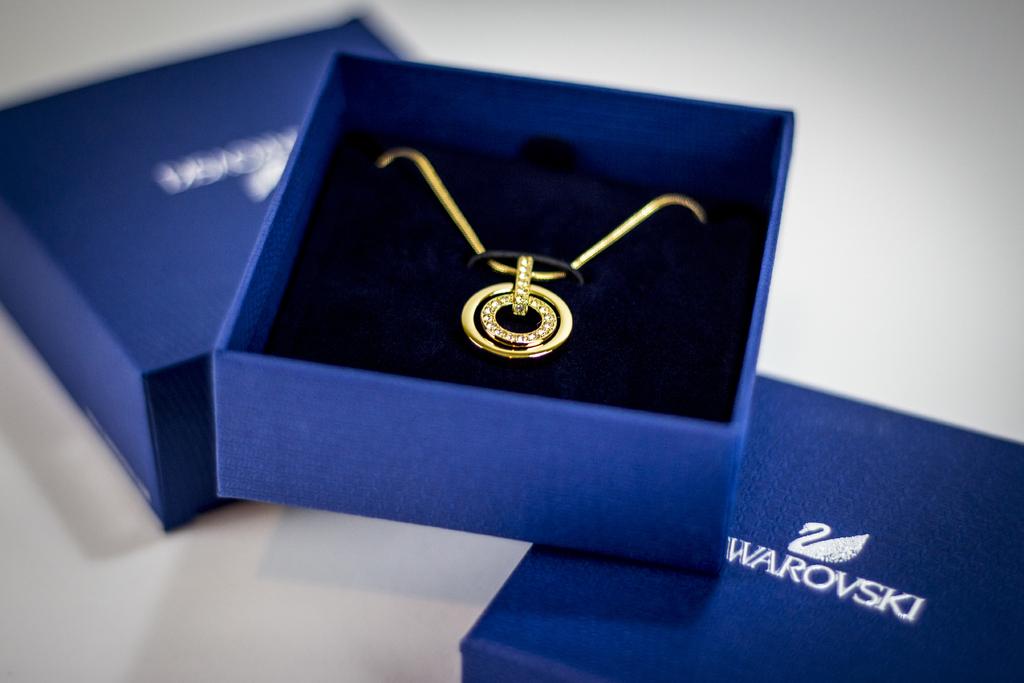What is the name of the company logo printed on the blue box?
Your response must be concise. Swarovski. 